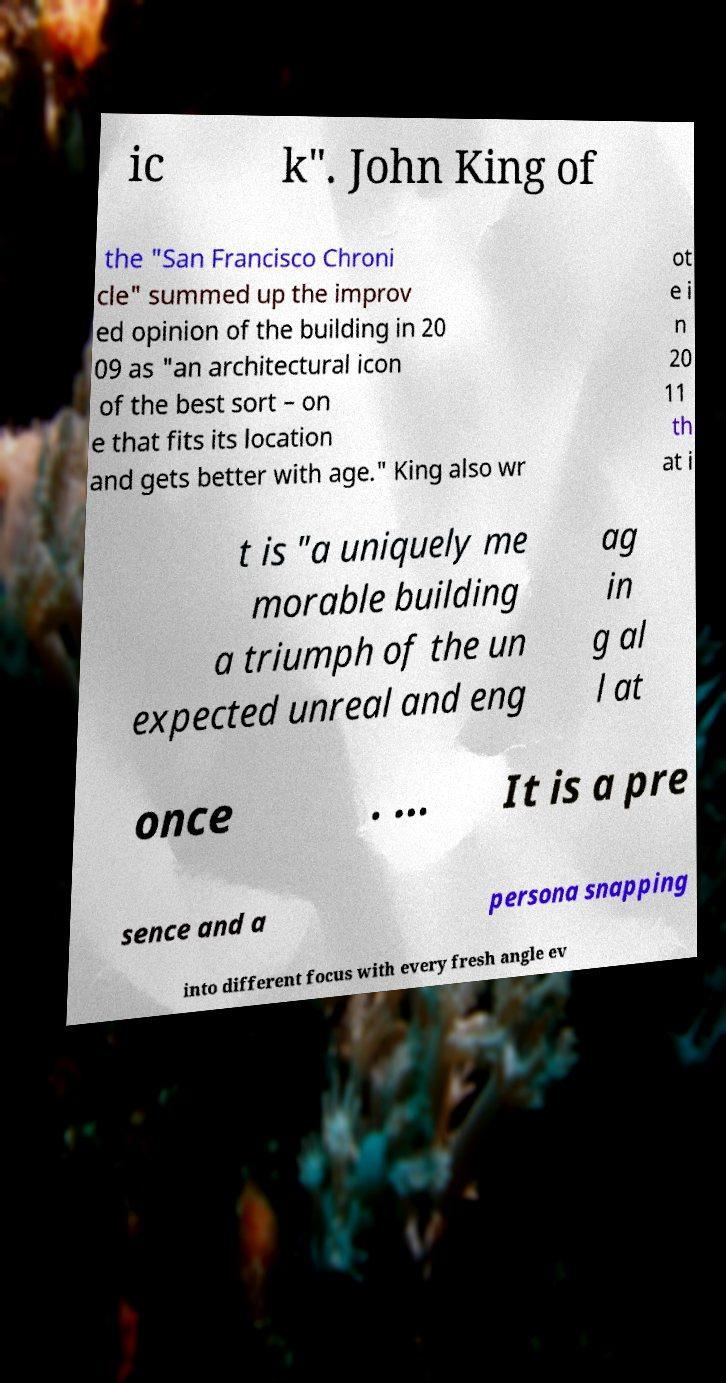For documentation purposes, I need the text within this image transcribed. Could you provide that? ic k". John King of the "San Francisco Chroni cle" summed up the improv ed opinion of the building in 20 09 as "an architectural icon of the best sort – on e that fits its location and gets better with age." King also wr ot e i n 20 11 th at i t is "a uniquely me morable building a triumph of the un expected unreal and eng ag in g al l at once . ... It is a pre sence and a persona snapping into different focus with every fresh angle ev 